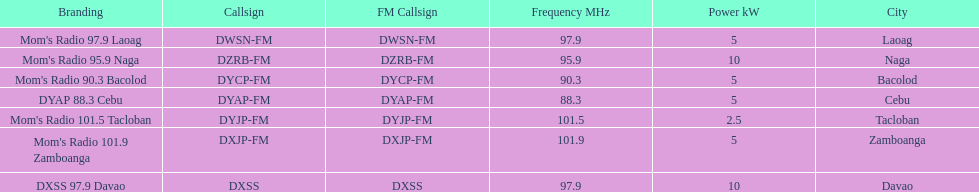What is the only radio station with a frequency below 90 mhz? DYAP 88.3 Cebu. Can you parse all the data within this table? {'header': ['Branding', 'Callsign', 'FM Callsign', 'Frequency MHz', 'Power kW', 'City'], 'rows': [["Mom's Radio 97.9 Laoag", 'DWSN-FM', 'DWSN-FM', '97.9', '5', 'Laoag'], ["Mom's Radio 95.9 Naga", 'DZRB-FM', 'DZRB-FM', '95.9', '10', 'Naga'], ["Mom's Radio 90.3 Bacolod", 'DYCP-FM', 'DYCP-FM', '90.3', '5', 'Bacolod'], ['DYAP 88.3 Cebu', 'DYAP-FM', 'DYAP-FM', '88.3', '5', 'Cebu'], ["Mom's Radio 101.5 Tacloban", 'DYJP-FM', 'DYJP-FM', '101.5', '2.5', 'Tacloban'], ["Mom's Radio 101.9 Zamboanga", 'DXJP-FM', 'DXJP-FM', '101.9', '5', 'Zamboanga'], ['DXSS 97.9 Davao', 'DXSS', 'DXSS', '97.9', '10', 'Davao']]} 